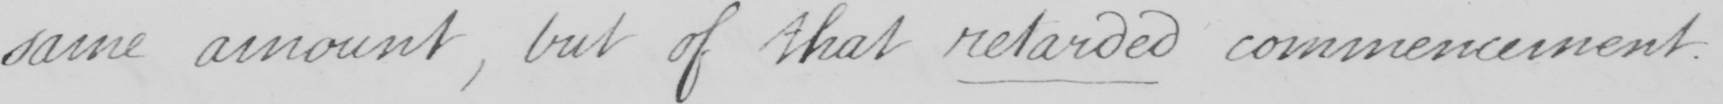What is written in this line of handwriting? same amount , but of that retarded commencement . 